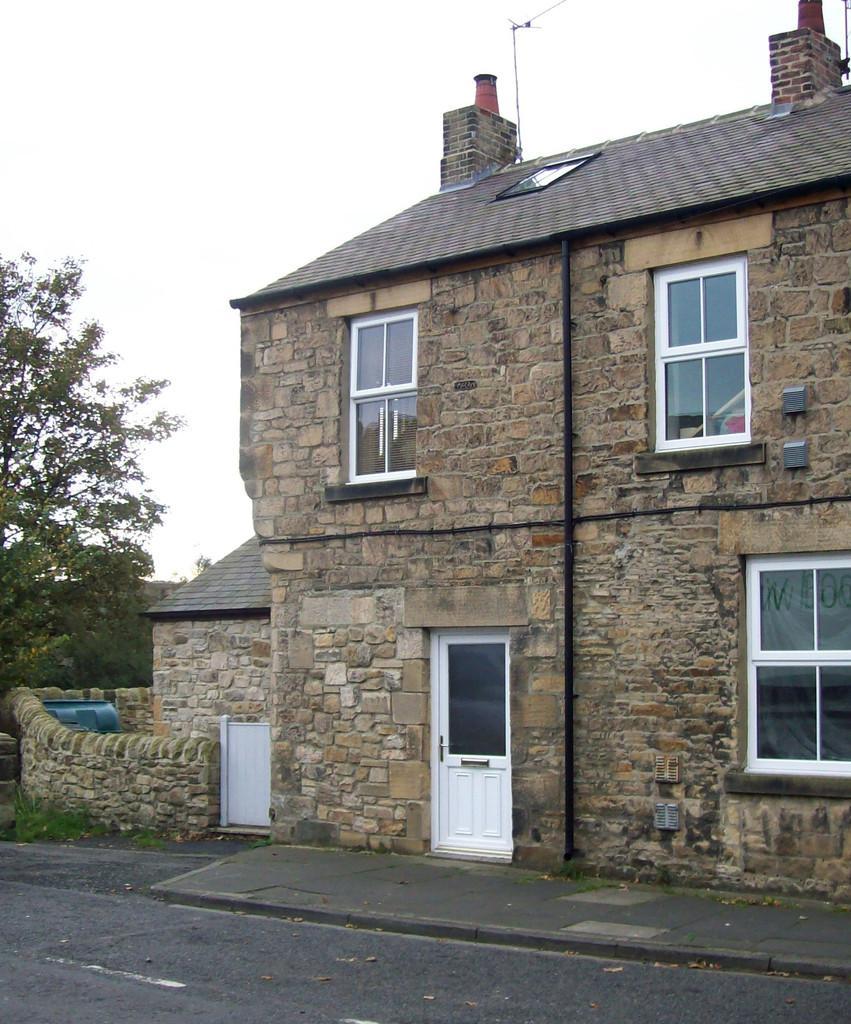Could you give a brief overview of what you see in this image? In this image I can see a building which has a white door and windows. There is a tree on the left. There is sky at the top. 